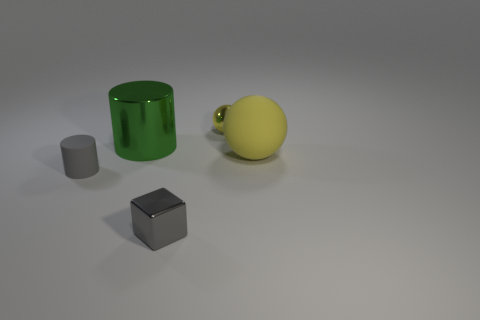There is a small cylinder that is the same color as the tiny metal cube; what is its material?
Give a very brief answer. Rubber. Do the large metallic object that is right of the small rubber thing and the rubber object to the left of the block have the same shape?
Your response must be concise. Yes. What number of other objects are the same color as the tiny sphere?
Provide a short and direct response. 1. There is a ball on the right side of the small metal object that is behind the big yellow rubber object on the right side of the small shiny sphere; what is its material?
Give a very brief answer. Rubber. What is the material of the big thing that is left of the shiny object that is to the right of the gray shiny cube?
Offer a very short reply. Metal. Are there fewer small gray rubber objects to the right of the tiny gray cube than big green cylinders?
Ensure brevity in your answer.  Yes. There is a yellow object behind the yellow rubber thing; what shape is it?
Offer a very short reply. Sphere. There is a yellow shiny sphere; is its size the same as the shiny thing in front of the green shiny cylinder?
Your answer should be compact. Yes. Are there any big green objects that have the same material as the big green cylinder?
Your response must be concise. No. How many cylinders are tiny shiny things or large green metallic things?
Provide a succinct answer. 1. 